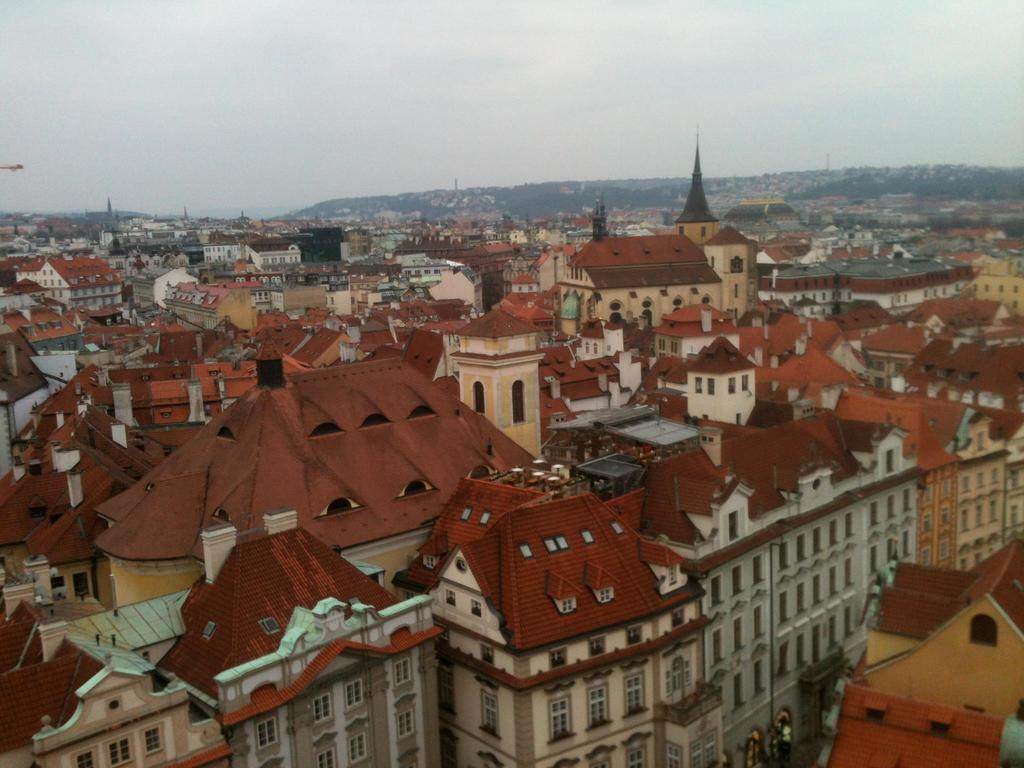What types of structures are visible in the image? There are houses, buildings, and towers in the image. What natural elements can be seen in the image? There are trees and mountains in the image. What architectural features are present in the image? There are windows visible in the structures. What part of the natural environment is visible in the image? The sky is visible in the image. How might the image have been captured? The image may have been taken from a top view. What type of copper material can be seen in the image? There is no copper material present in the image. What is the temperature like in the image? The image does not provide information about the temperature, as it only shows structures, trees, mountains, and the sky. 